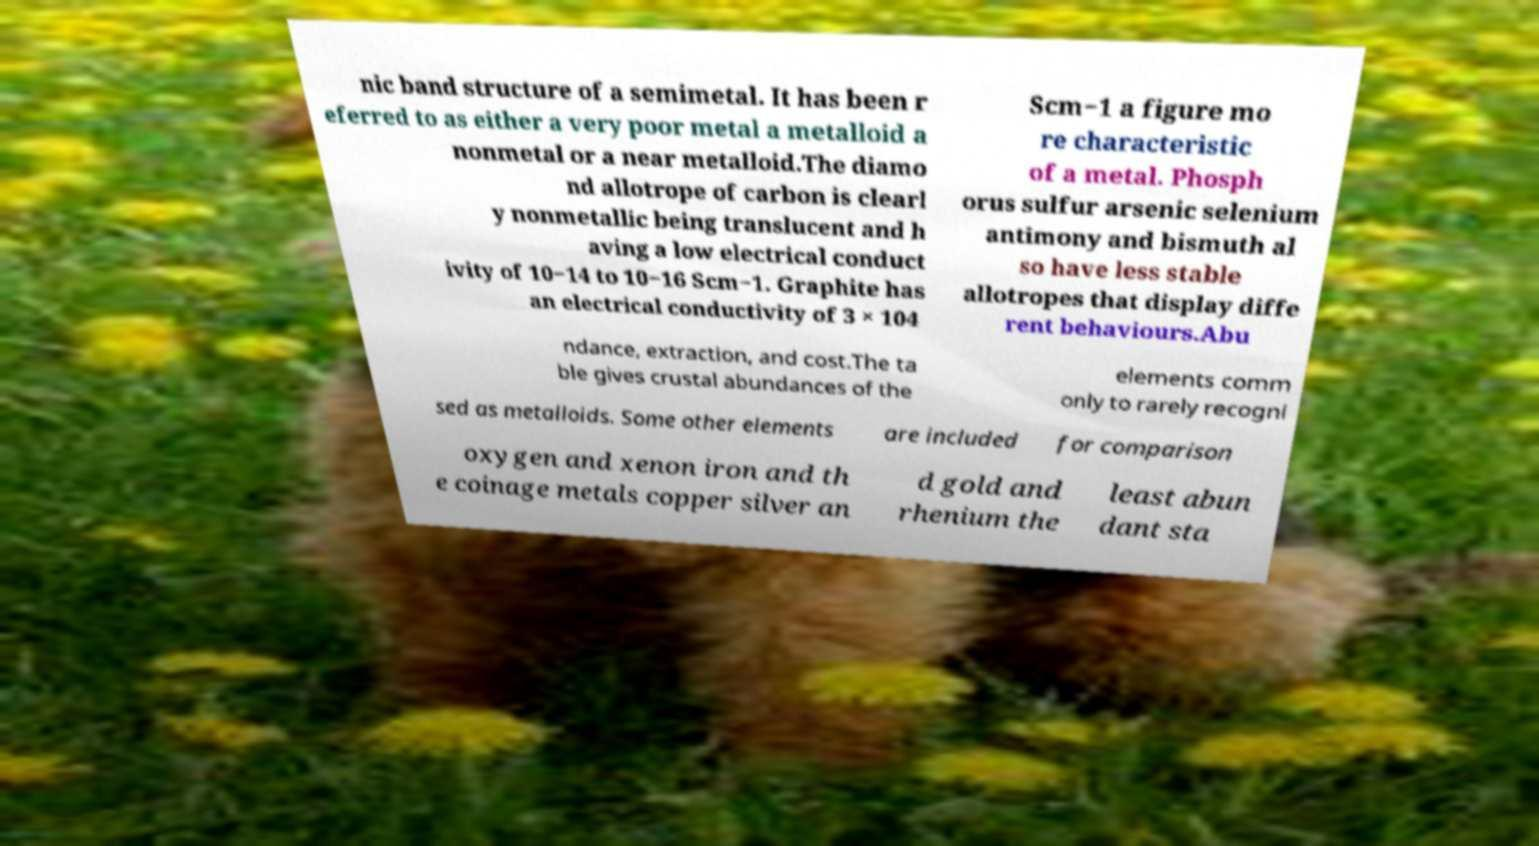For documentation purposes, I need the text within this image transcribed. Could you provide that? nic band structure of a semimetal. It has been r eferred to as either a very poor metal a metalloid a nonmetal or a near metalloid.The diamo nd allotrope of carbon is clearl y nonmetallic being translucent and h aving a low electrical conduct ivity of 10−14 to 10−16 Scm−1. Graphite has an electrical conductivity of 3 × 104 Scm−1 a figure mo re characteristic of a metal. Phosph orus sulfur arsenic selenium antimony and bismuth al so have less stable allotropes that display diffe rent behaviours.Abu ndance, extraction, and cost.The ta ble gives crustal abundances of the elements comm only to rarely recogni sed as metalloids. Some other elements are included for comparison oxygen and xenon iron and th e coinage metals copper silver an d gold and rhenium the least abun dant sta 